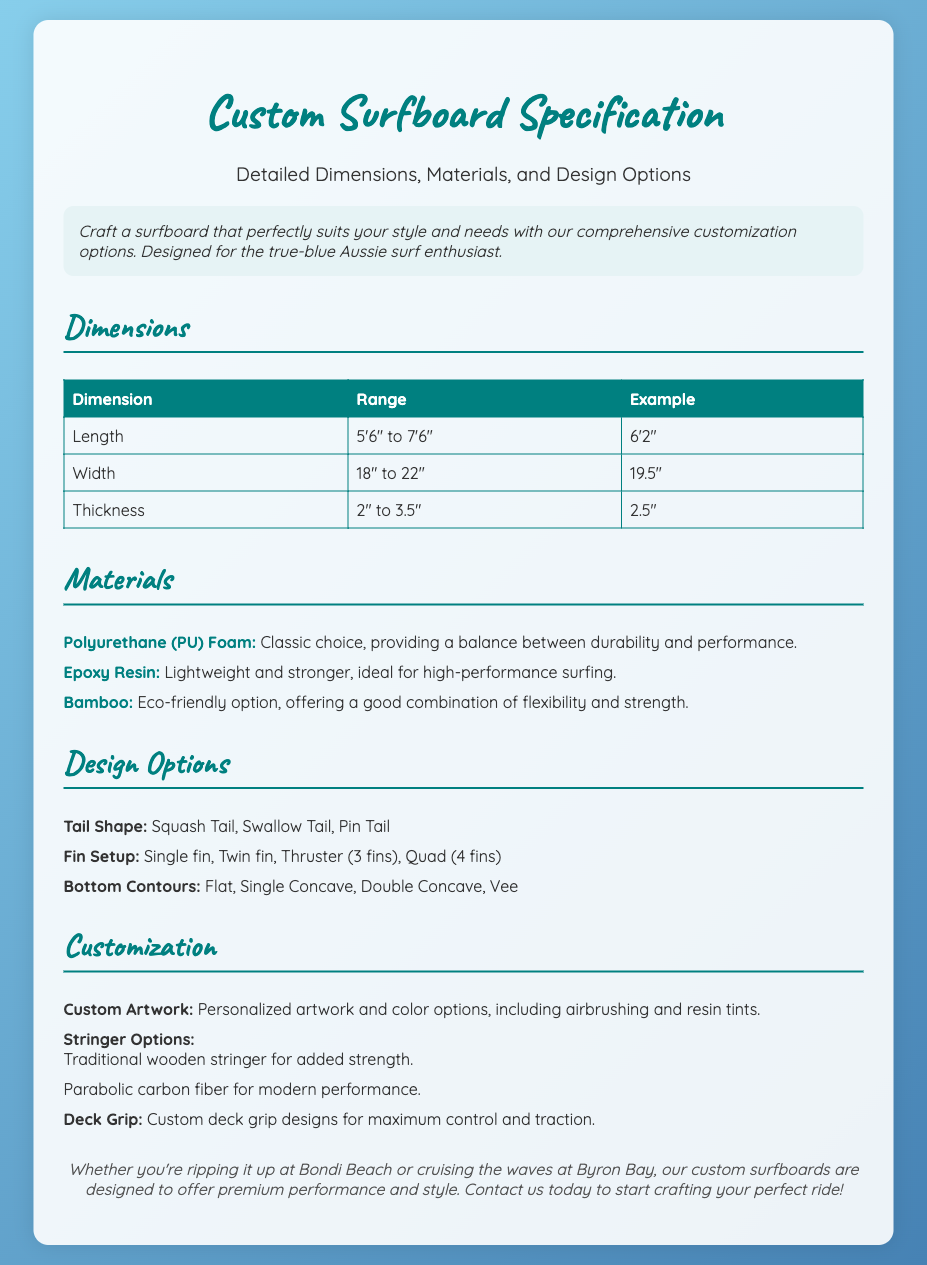What is the minimum length for a custom surfboard? The minimum length for a custom surfboard is found in the dimensions section, specifically under Length.
Answer: 5'6" What is the maximum thickness available? The maximum thickness is noted in the dimensions section, specifically under Thickness.
Answer: 3.5" Which material is considered eco-friendly? The eco-friendly material is listed in the Materials section.
Answer: Bamboo What are the available tail shapes? The available tail shapes can be found in the Design Options section, under Tail Shape.
Answer: Squash Tail, Swallow Tail, Pin Tail What custom options are available for artwork? The custom options for artwork are described in the Customization section.
Answer: Personalized artwork and color options What fin setups are offered? The fin setups are mentioned in the Design Options section.
Answer: Single fin, Twin fin, Thruster, Quad What type of foam is a classic choice for surfboards? The classic choice of foam is identified in the Materials section.
Answer: Polyurethane (PU) Foam How many dimensions are listed in the document? Counting the dimensions sections shows how many specific dimensions are included in the document.
Answer: Three What is the suggested way to contact for customization? The suggested contact method is found in the footer of the document.
Answer: Contact us today 